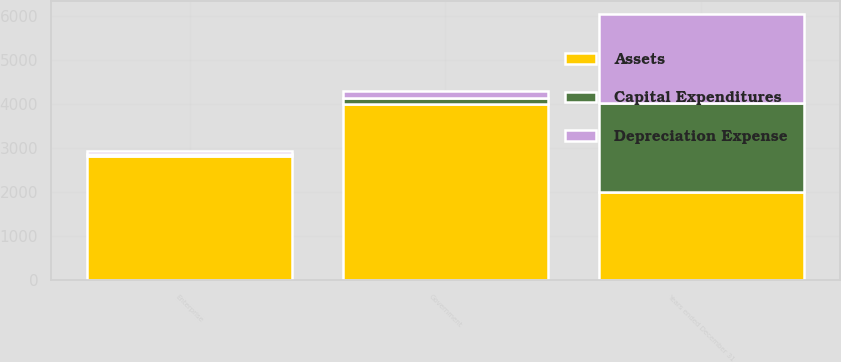Convert chart. <chart><loc_0><loc_0><loc_500><loc_500><stacked_bar_chart><ecel><fcel>Years ended December 31<fcel>Government<fcel>Enterprise<nl><fcel>Assets<fcel>2013<fcel>4013<fcel>2820<nl><fcel>Capital Expenditures<fcel>2013<fcel>132<fcel>59<nl><fcel>Depreciation Expense<fcel>2013<fcel>154<fcel>48<nl></chart> 